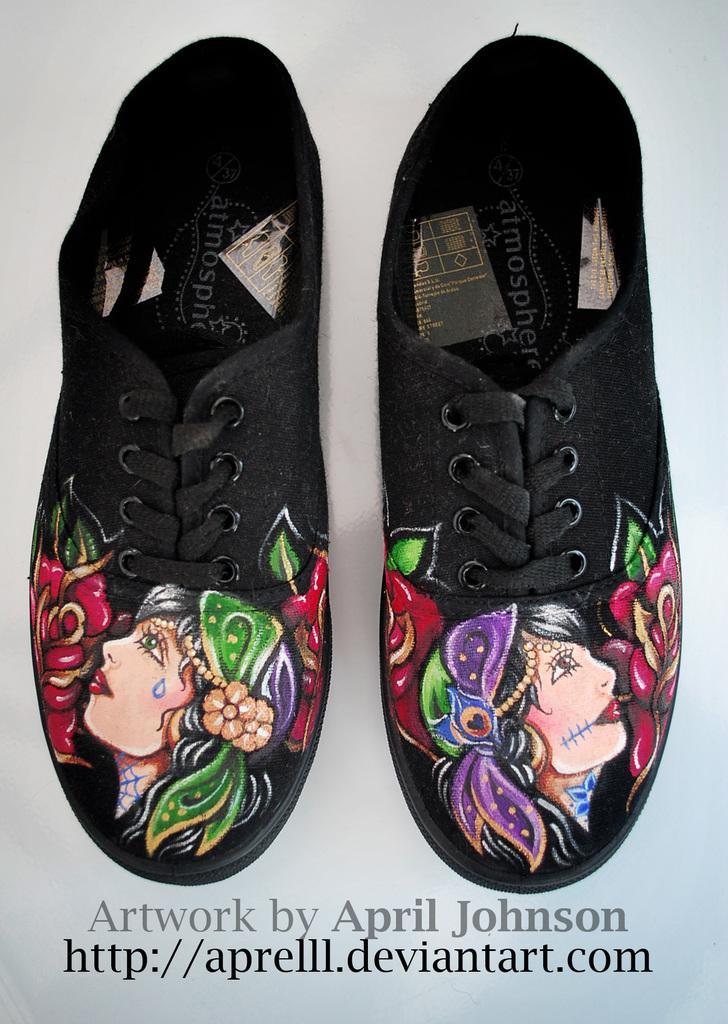Please provide a concise description of this image. In this picture there are two black color shoes in the center of the image. 